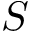<formula> <loc_0><loc_0><loc_500><loc_500>S</formula> 